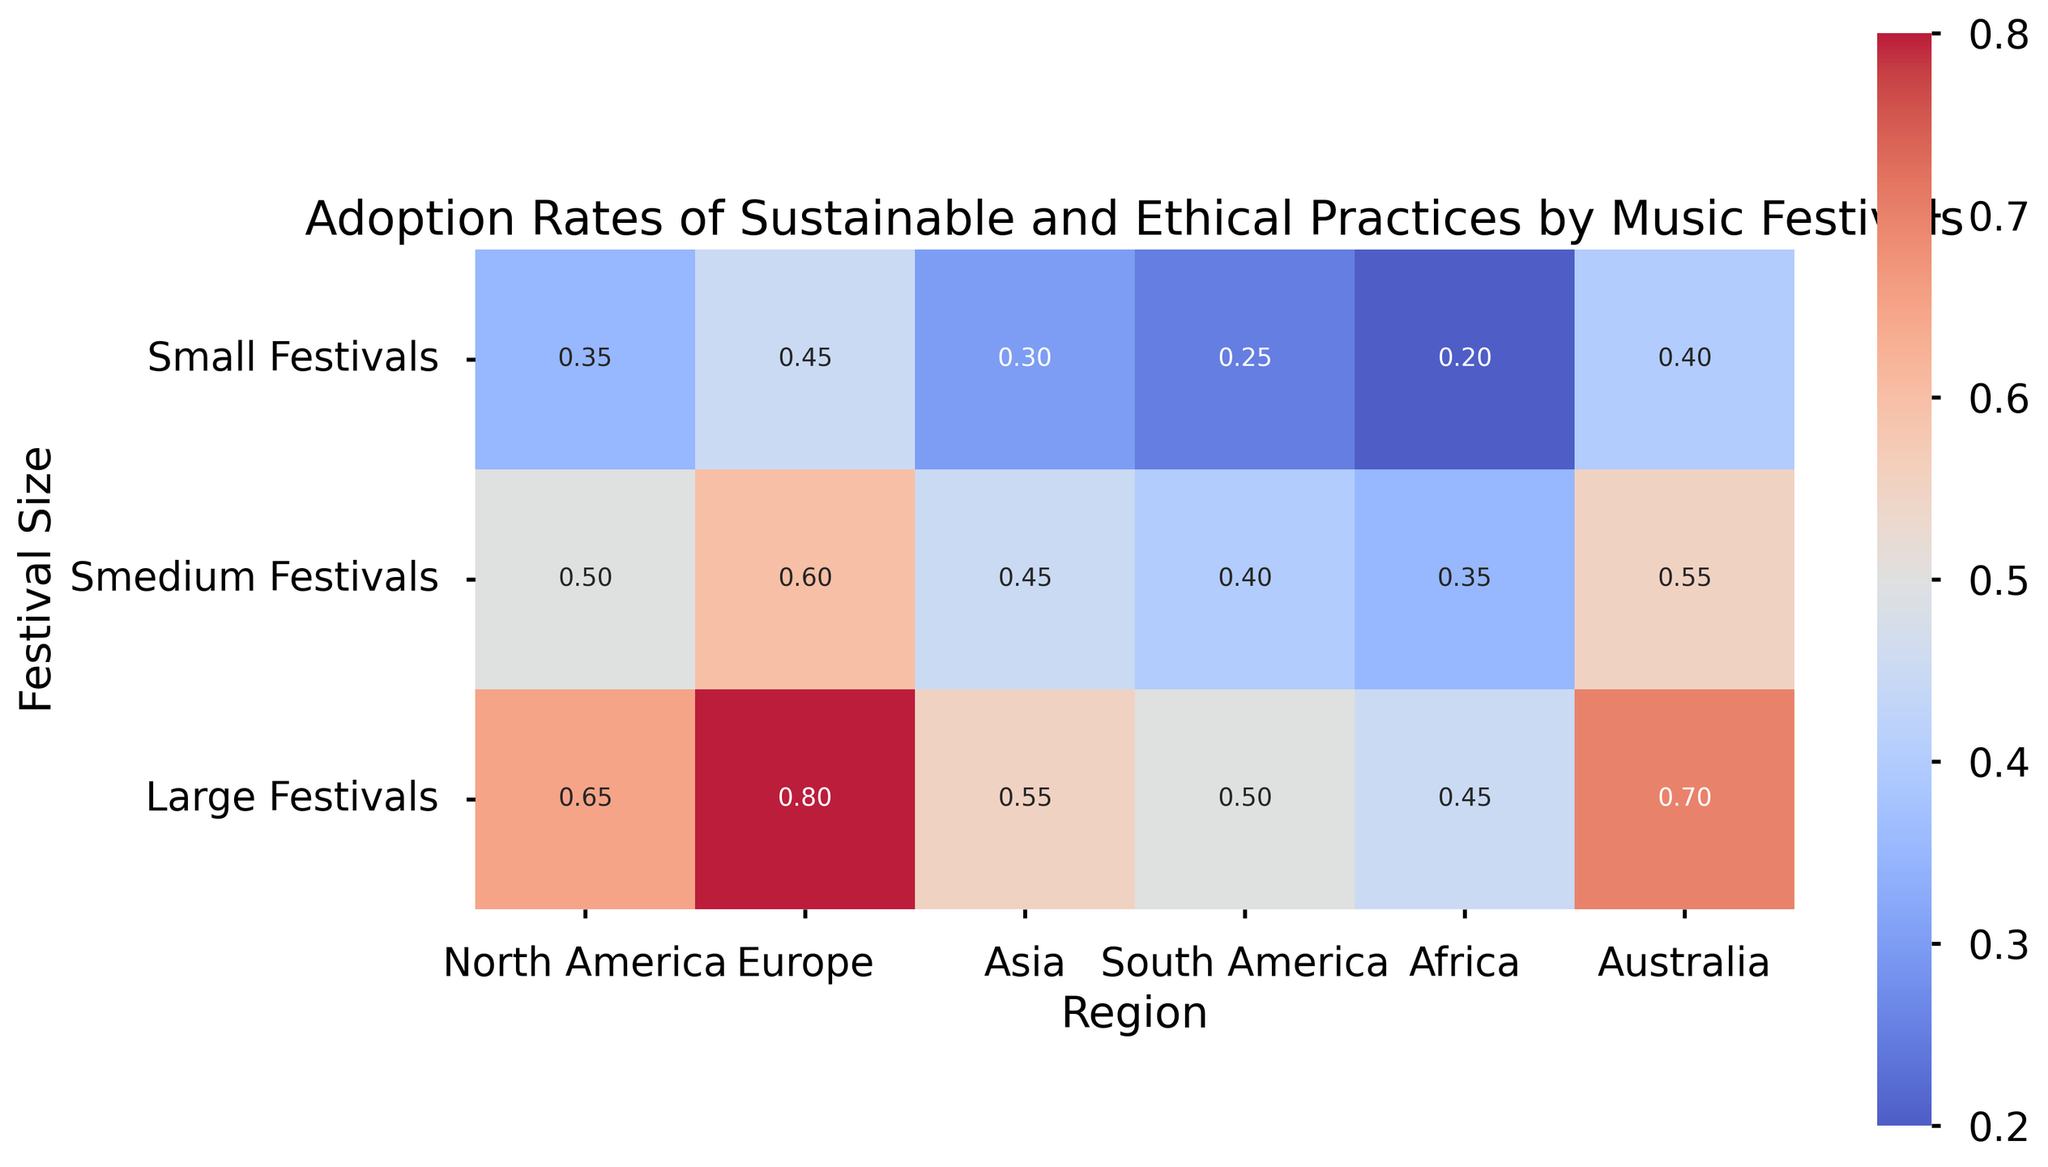What is the adoption rate of sustainable and ethical practices by large festivals in Europe? The heatmap shows the value at the intersection of the row for "Europe" and the column for "Large Festivals." This value is listed as 0.80.
Answer: 0.80 Which region has the lowest adoption rate for small festivals? By looking at the row labeled "Small Festivals," the heatmap shows that "Africa" has the lowest value, which is 0.20.
Answer: Africa Compare the adoption rates for medium festivals between North America and Australia. Which is higher? The values for medium festivals are shown for "North America" (0.50) and "Australia" (0.55). Comparing these, 0.55 (Australia) is higher than 0.50 (North America).
Answer: Australia What is the average adoption rate for large festivals across all regions? The values for large festivals across all regions are 0.65, 0.80, 0.55, 0.50, 0.45, and 0.70. Summing these gives 3.65. Dividing by the 6 regions gives an average of 3.65/6 ≈ 0.61.
Answer: 0.61 Which festival size has the most consistent adoption rates across all regions, and why? The consistency can be checked by observing the variation in the values for each festival size. "Small Festivals" have values 0.35, 0.45, 0.30, 0.25, 0.20, and 0.40, while "Medium Festivals" have values 0.50, 0.60, 0.45, 0.40, 0.35, and 0.55. "Large Festivals" have values 0.65, 0.80, 0.55, 0.50, 0.45, and 0.70. "Medium Festivals" show the least variation.
Answer: Medium Festivals What is the difference in adoption rates between small and large festivals in South America? The adoption rates for "South America" are 0.25 for small festivals and 0.50 for large festivals. The difference is 0.50 - 0.25 = 0.25.
Answer: 0.25 How does the adoption rate of small festivals in North America compare to that in Asia? The adoption rates for small festivals are 0.35 in North America and 0.30 in Asia. Therefore, North America's adoption rate is higher.
Answer: North America In which region do large festivals adopt sustainable practices at a rate greater than 0.60, and what are those rates? From the heatmap, regions with large festival rates > 0.60 are "North America" (0.65), "Europe" (0.80), and "Australia" (0.70).
Answer: North America (0.65), Europe (0.80), Australia (0.70) Calculate the overall average adoption rate for all festivals in Asia. Summing the values for Asia (0.30, 0.45, 0.55) gives 1.30. Dividing by 3 festival sizes results in an average of 1.30/3 ≈ 0.43.
Answer: 0.43 